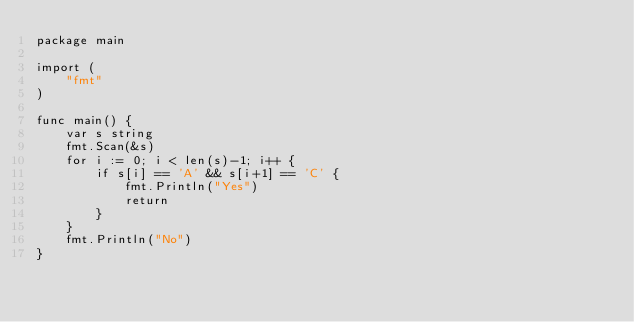<code> <loc_0><loc_0><loc_500><loc_500><_Go_>package main

import (
	"fmt"
)

func main() {
	var s string
	fmt.Scan(&s)
	for i := 0; i < len(s)-1; i++ {
		if s[i] == 'A' && s[i+1] == 'C' {
			fmt.Println("Yes")
			return
		}
	}
	fmt.Println("No")
}
</code> 